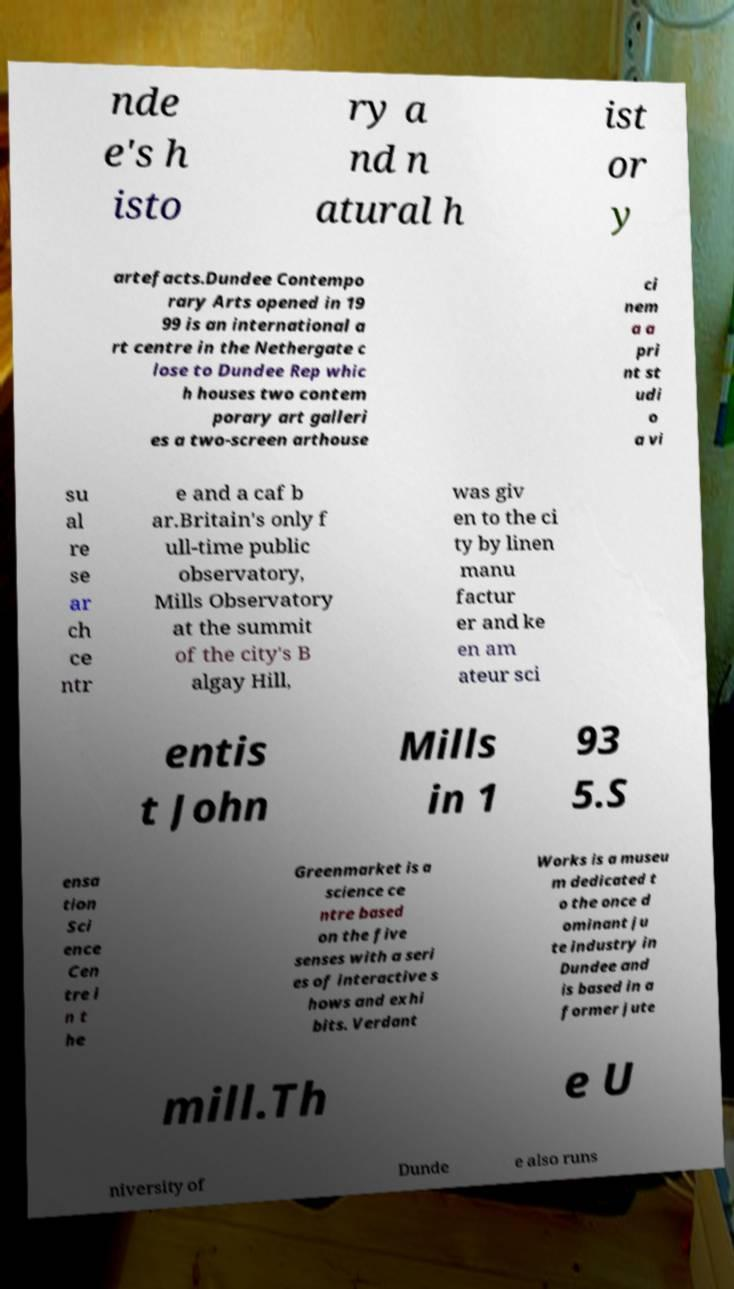What messages or text are displayed in this image? I need them in a readable, typed format. nde e's h isto ry a nd n atural h ist or y artefacts.Dundee Contempo rary Arts opened in 19 99 is an international a rt centre in the Nethergate c lose to Dundee Rep whic h houses two contem porary art galleri es a two-screen arthouse ci nem a a pri nt st udi o a vi su al re se ar ch ce ntr e and a caf b ar.Britain's only f ull-time public observatory, Mills Observatory at the summit of the city's B algay Hill, was giv en to the ci ty by linen manu factur er and ke en am ateur sci entis t John Mills in 1 93 5.S ensa tion Sci ence Cen tre i n t he Greenmarket is a science ce ntre based on the five senses with a seri es of interactive s hows and exhi bits. Verdant Works is a museu m dedicated t o the once d ominant ju te industry in Dundee and is based in a former jute mill.Th e U niversity of Dunde e also runs 